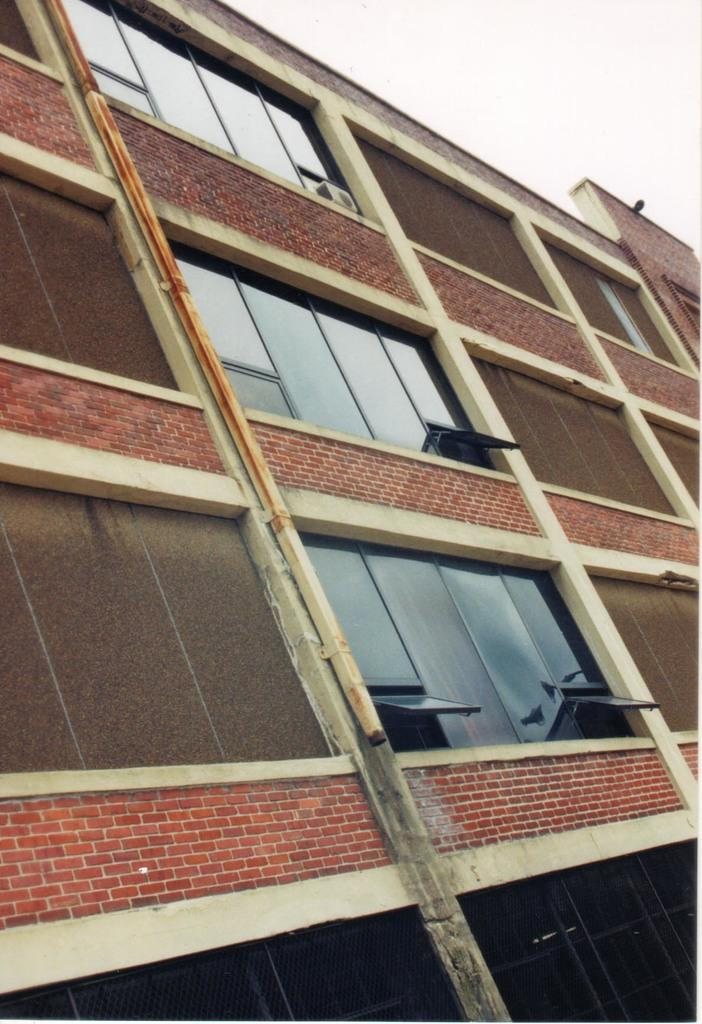What type of structure is present in the image? There is a building in the image. What features can be observed on the building? The building has windows and an air conditioner. What can be seen in the background of the image? The sky is visible in the background of the image. What type of pump is visible in the image? There is no pump present in the image. What station is located near the building in the image? There is no station mentioned or visible in the image. 